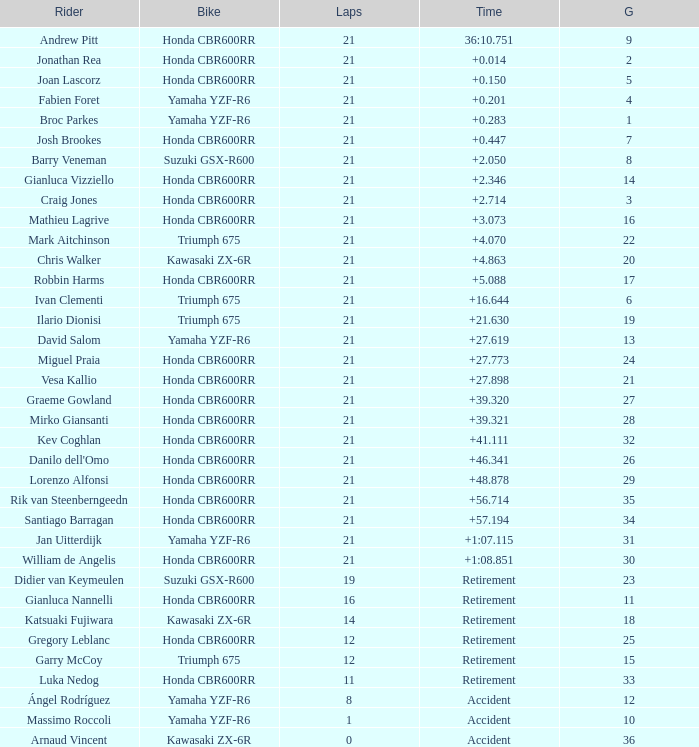Who is the competitor with under 16 laps, a grid ranking of 10, operating a yamaha yzf-r6, and terminating with an accident? Massimo Roccoli. 